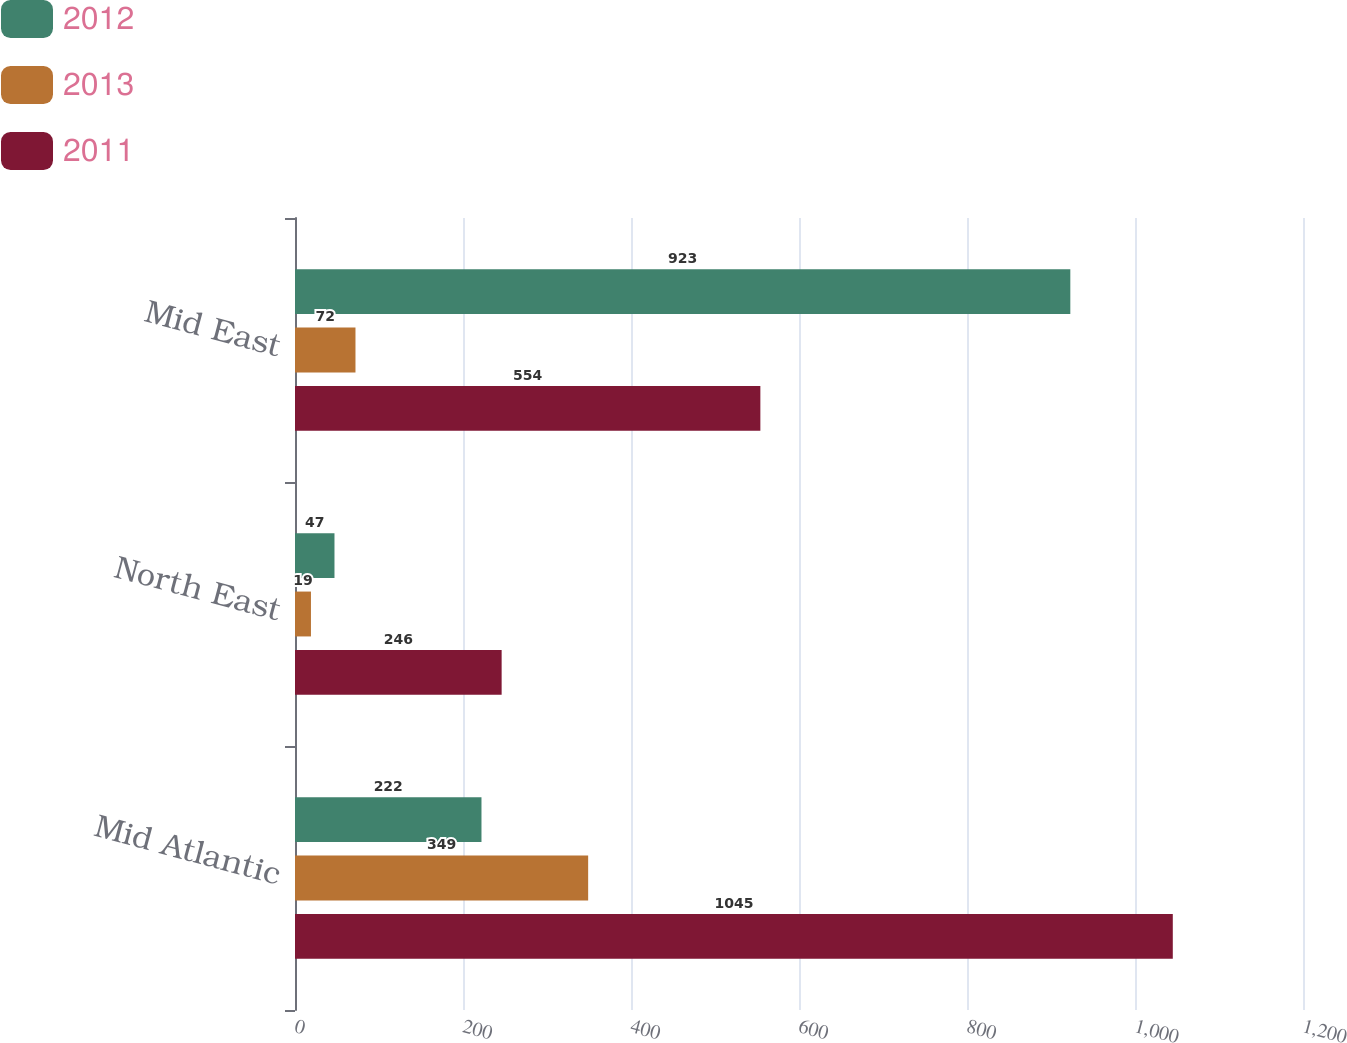<chart> <loc_0><loc_0><loc_500><loc_500><stacked_bar_chart><ecel><fcel>Mid Atlantic<fcel>North East<fcel>Mid East<nl><fcel>2012<fcel>222<fcel>47<fcel>923<nl><fcel>2013<fcel>349<fcel>19<fcel>72<nl><fcel>2011<fcel>1045<fcel>246<fcel>554<nl></chart> 